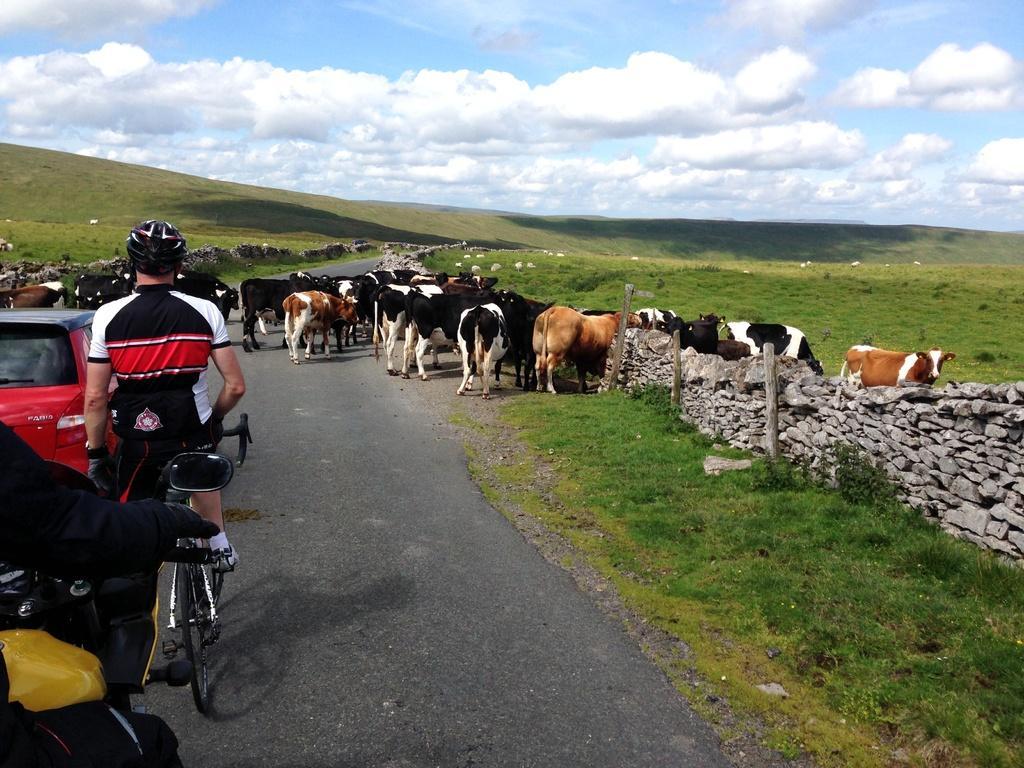In one or two sentences, can you explain what this image depicts? In this image, we can see a few people and some vehicles. We can see a bicycle. We can see the ground and some animals. We can see some grass, stones and poles. We can also see the sky with clouds. 